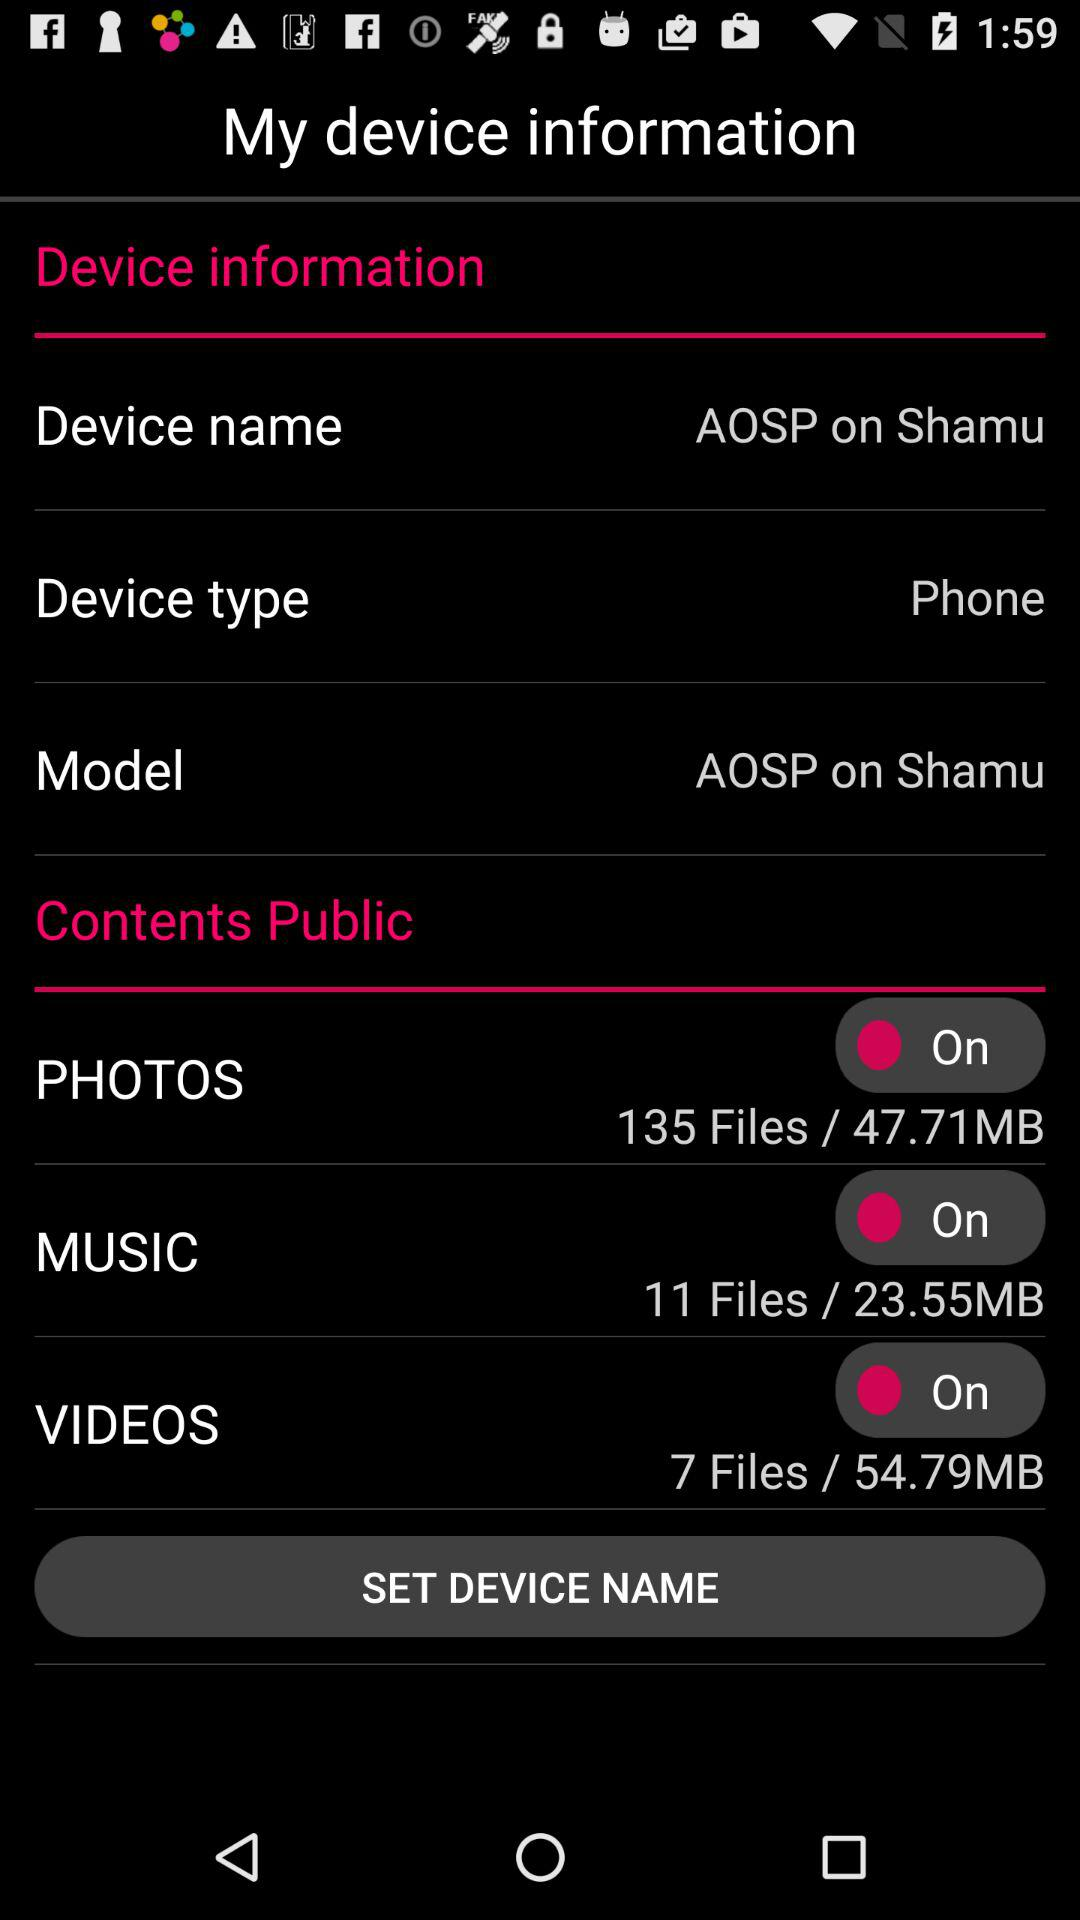How many megabytes are used by music? There are 23.55 megabytes used by the music. 